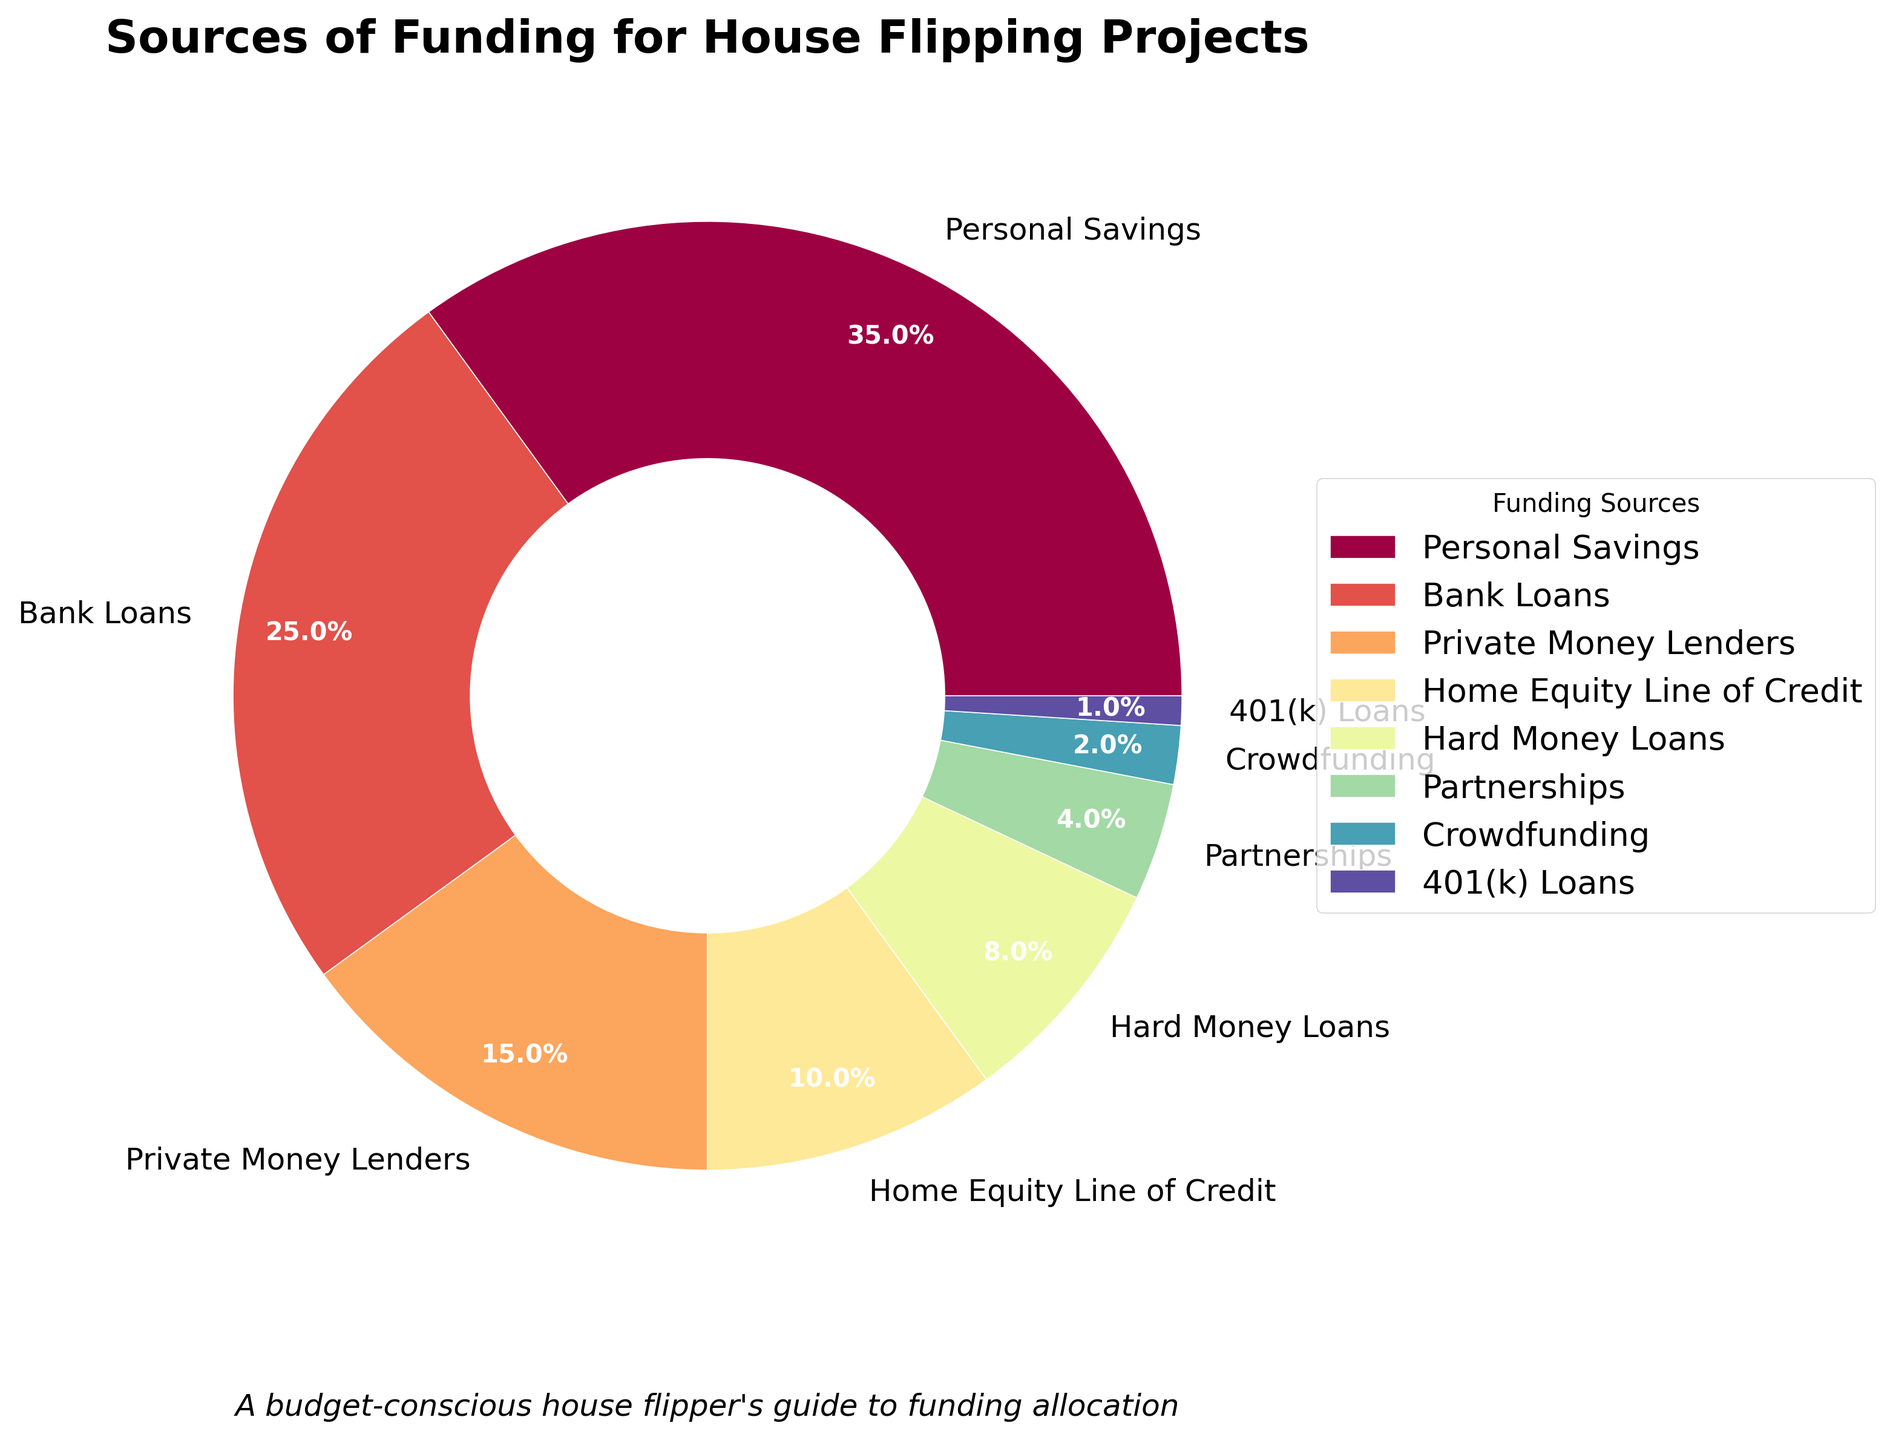What's the most common source of funding? The section of the pie chart with the largest percentage represents the most common source of funding. Personal Savings is 35%, which is the largest segment.
Answer: Personal Savings Which source of funding is the least common? The section of the pie chart with the smallest percentage represents the least common source of funding. 401(k) Loans have 1%, which is the smallest segment.
Answer: 401(k) Loans What is the combined percentage of Bank Loans and Private Money Lenders? Bank Loans represent 25% and Private Money Lenders represent 15%. Adding these two percentages gives 25% + 15% = 40%.
Answer: 40% Do Home Equity Line of Credit (HELOC) and Hard Money Loans together account for more or less than Partnerships and Crowdfunding combined? HELOC is 10% and Hard Money Loans are 8%, totaling 18%. Partnerships are 4% and Crowdfunding is 2%, totaling 6%. Comparing 18% and 6%, 18% is more.
Answer: More Which funding source ranks second in terms of percentage? The second-largest section in the pie chart indicates the second most common source of funding. After Personal Savings (35%), Bank Loans are next at 25%.
Answer: Bank Loans What is the percentage difference between Personal Savings and Hard Money Loans? Personal Savings is 35% and Hard Money Loans are 8%. The difference is 35% - 8% = 27%.
Answer: 27% How much more common are Private Money Lenders compared to Partnerships? Private Money Lenders account for 15%, and Partnerships account for 4%. The difference is 15% - 4% = 11%.
Answer: 11% Which sources of funding collectively contribute to less than 10% of the total funding? Crowdfunding (2%) and 401(k) Loans (1%) should together be 2% + 1% = 3%, which is less than 10%.
Answer: Crowdfunding and 401(k) Loans What is the average percentage of the funding sources listed? Sum the percentages: 35+25+15+10+8+4+2+1 = 100%, divided by the number of sources (8), 100% / 8 = 12.5%.
Answer: 12.5% How does the color corresponding to Bank Loans compare to the color corresponding to Crowdfunding? Since the pie chart uses a spectrum of colors, Bank Loans (25%) is likely a more central color, while Crowdfunding (2%) is nearer the start or end of the color spectrum. One might be a mid-spectrum color and the other an edge spectrum color.
Answer: Mid-spectrum vs. Edge-spectrum 